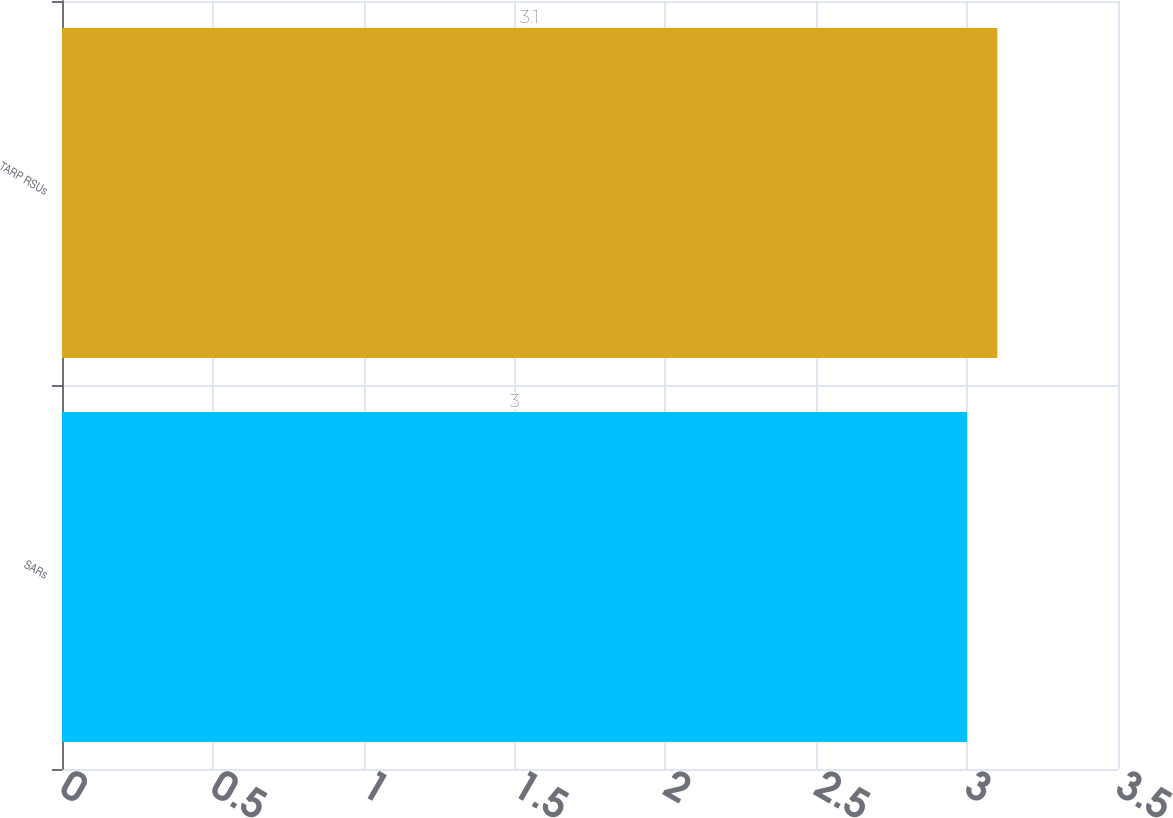Convert chart to OTSL. <chart><loc_0><loc_0><loc_500><loc_500><bar_chart><fcel>SARs<fcel>TARP RSUs<nl><fcel>3<fcel>3.1<nl></chart> 